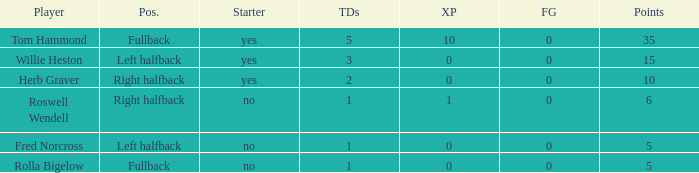What is the smallest number of field goals for a player with 3 touchdowns? 0.0. 